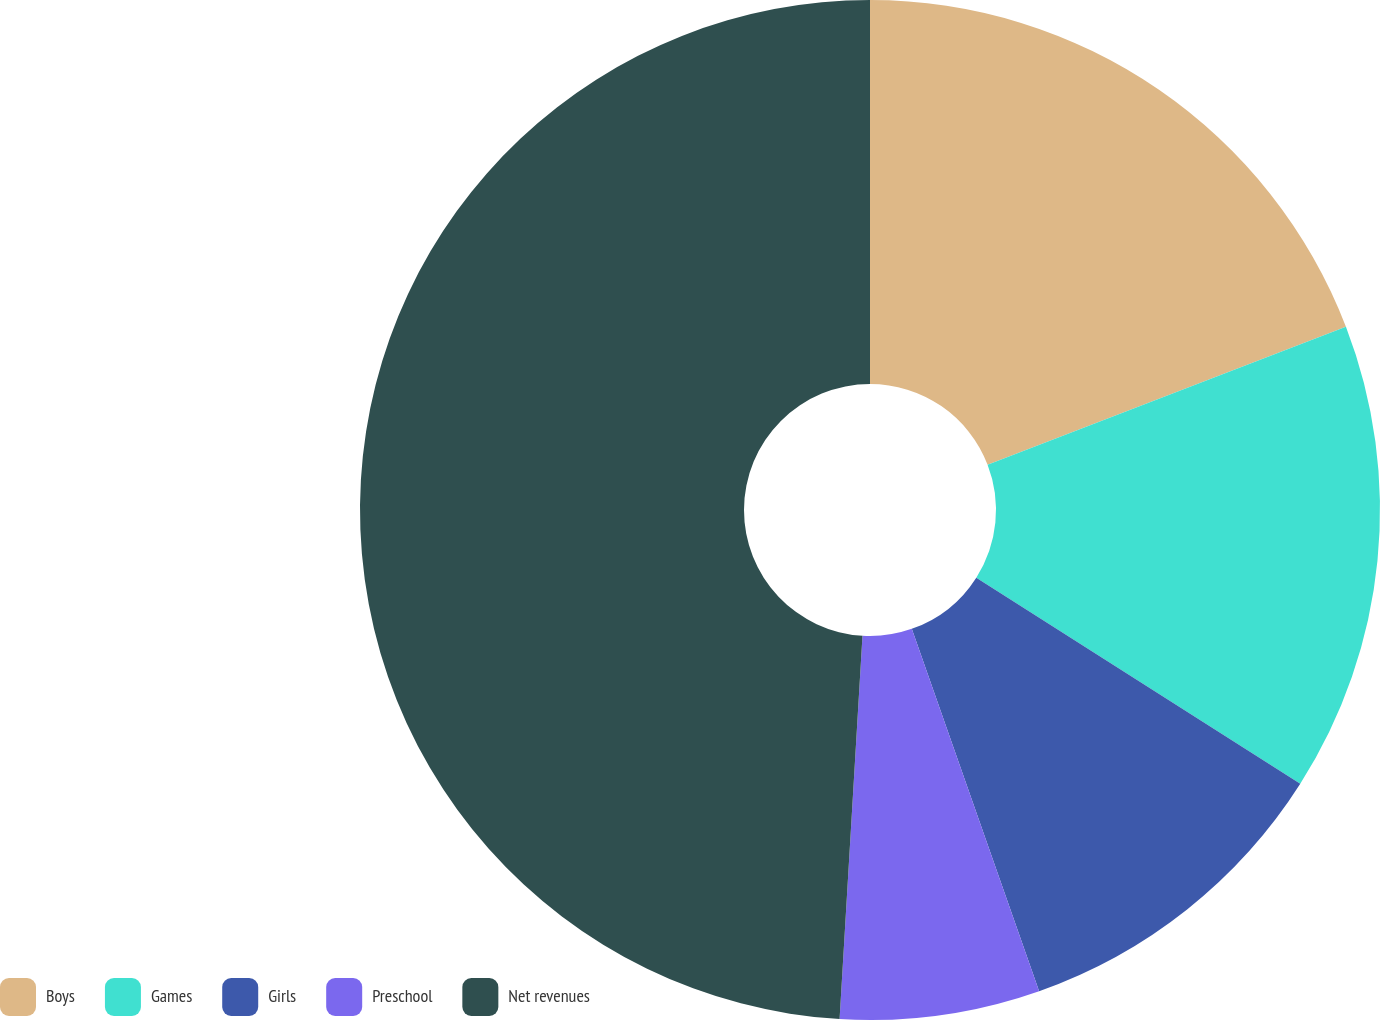<chart> <loc_0><loc_0><loc_500><loc_500><pie_chart><fcel>Boys<fcel>Games<fcel>Girls<fcel>Preschool<fcel>Net revenues<nl><fcel>19.15%<fcel>14.87%<fcel>10.6%<fcel>6.33%<fcel>49.05%<nl></chart> 